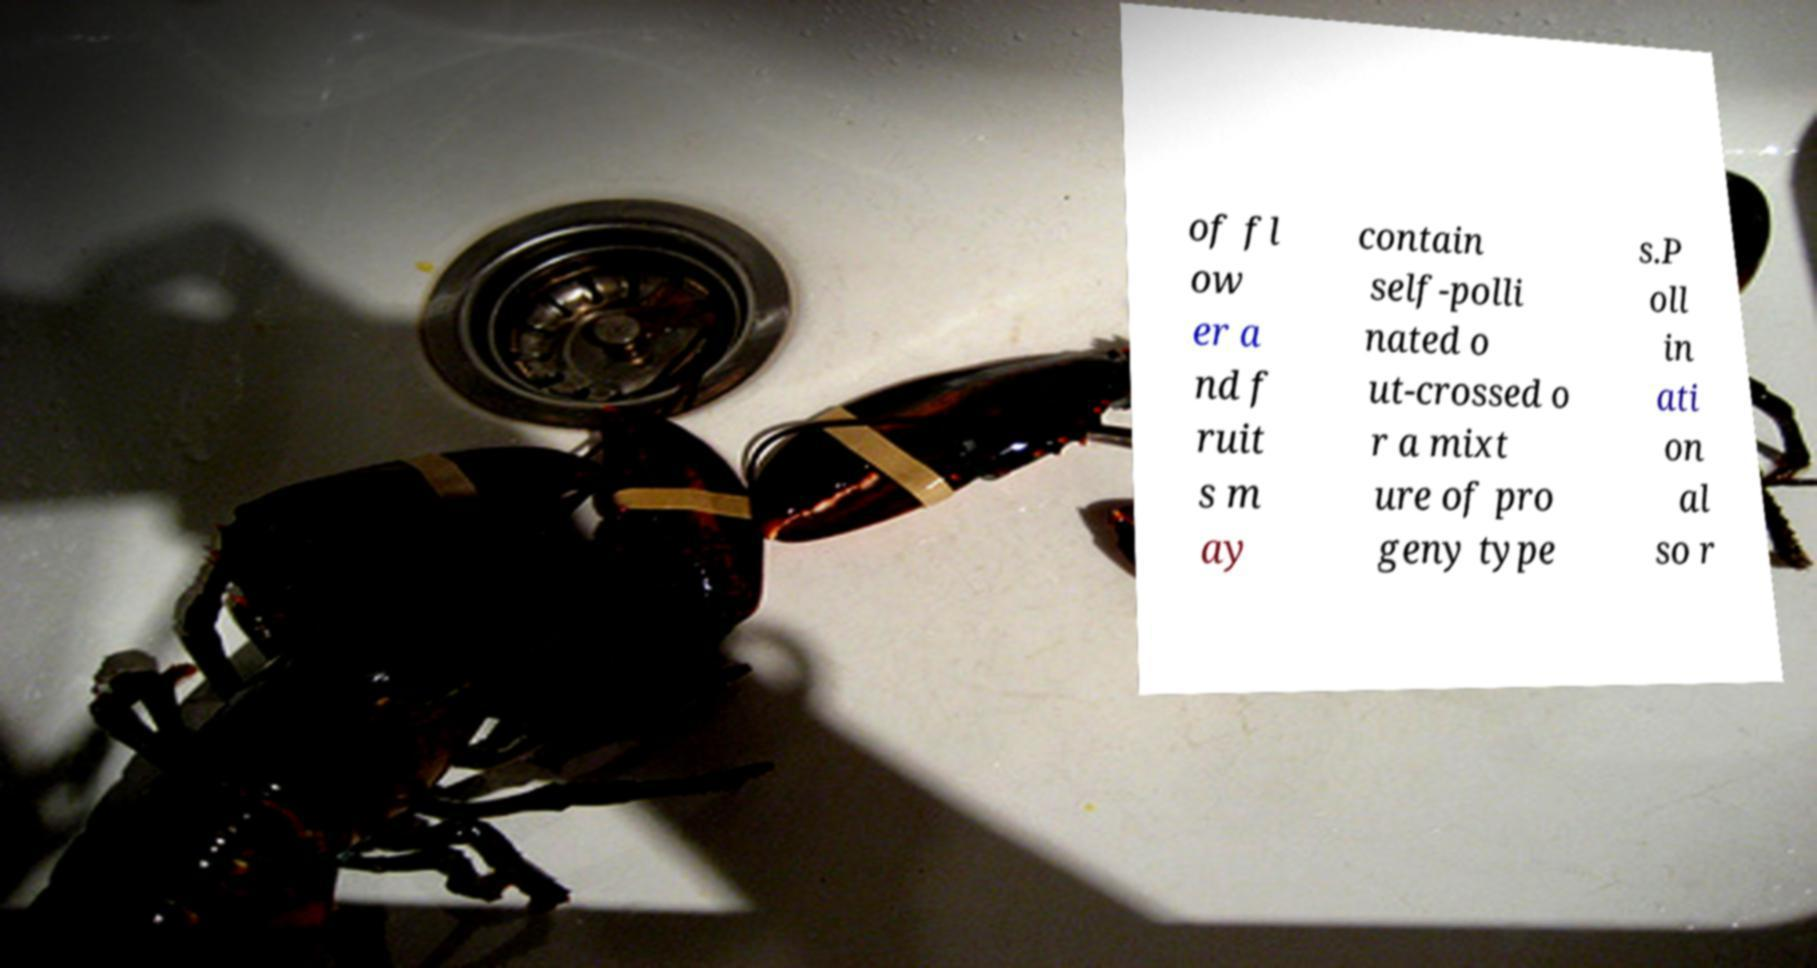For documentation purposes, I need the text within this image transcribed. Could you provide that? of fl ow er a nd f ruit s m ay contain self-polli nated o ut-crossed o r a mixt ure of pro geny type s.P oll in ati on al so r 